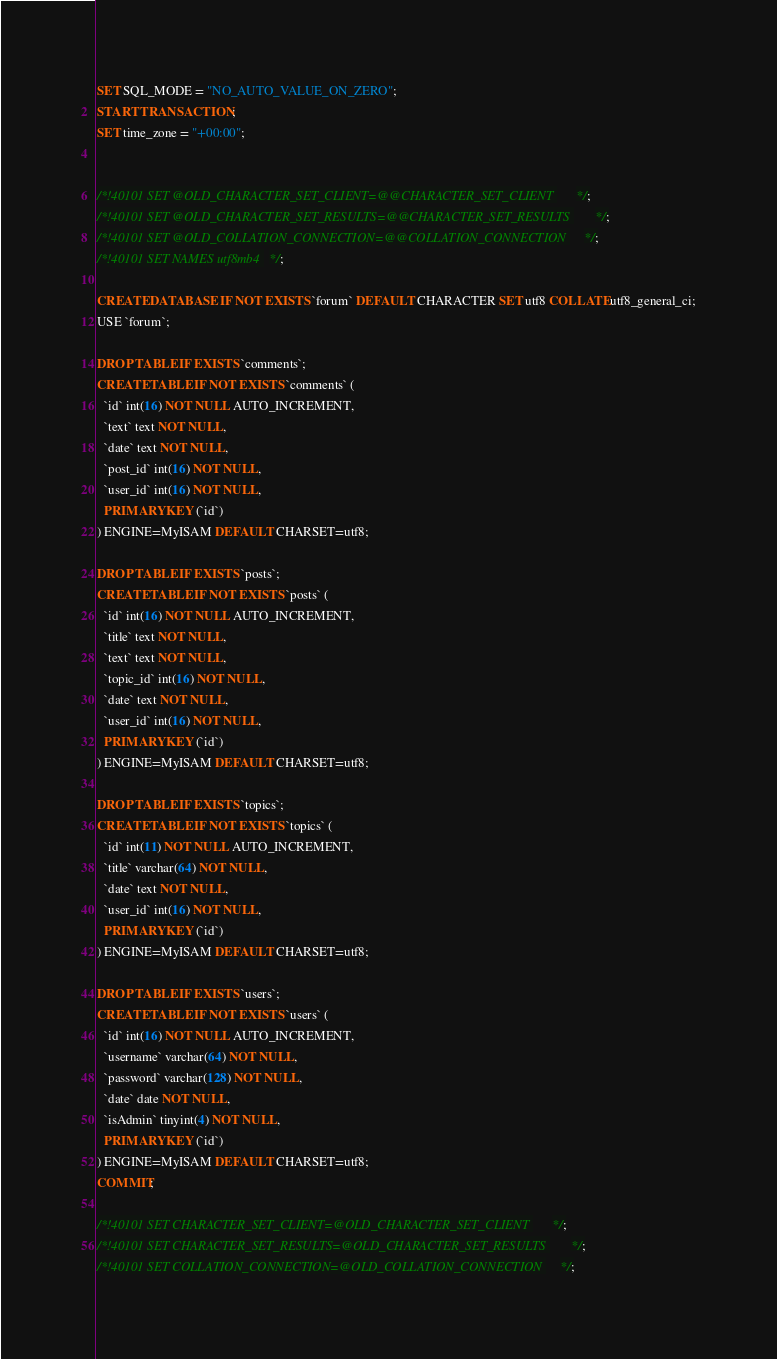<code> <loc_0><loc_0><loc_500><loc_500><_SQL_>SET SQL_MODE = "NO_AUTO_VALUE_ON_ZERO";
START TRANSACTION;
SET time_zone = "+00:00";


/*!40101 SET @OLD_CHARACTER_SET_CLIENT=@@CHARACTER_SET_CLIENT */;
/*!40101 SET @OLD_CHARACTER_SET_RESULTS=@@CHARACTER_SET_RESULTS */;
/*!40101 SET @OLD_COLLATION_CONNECTION=@@COLLATION_CONNECTION */;
/*!40101 SET NAMES utf8mb4 */;

CREATE DATABASE IF NOT EXISTS `forum` DEFAULT CHARACTER SET utf8 COLLATE utf8_general_ci;
USE `forum`;

DROP TABLE IF EXISTS `comments`;
CREATE TABLE IF NOT EXISTS `comments` (
  `id` int(16) NOT NULL AUTO_INCREMENT,
  `text` text NOT NULL,
  `date` text NOT NULL,
  `post_id` int(16) NOT NULL,
  `user_id` int(16) NOT NULL,
  PRIMARY KEY (`id`)
) ENGINE=MyISAM DEFAULT CHARSET=utf8;

DROP TABLE IF EXISTS `posts`;
CREATE TABLE IF NOT EXISTS `posts` (
  `id` int(16) NOT NULL AUTO_INCREMENT,
  `title` text NOT NULL,
  `text` text NOT NULL,
  `topic_id` int(16) NOT NULL,
  `date` text NOT NULL,
  `user_id` int(16) NOT NULL,
  PRIMARY KEY (`id`)
) ENGINE=MyISAM DEFAULT CHARSET=utf8;

DROP TABLE IF EXISTS `topics`;
CREATE TABLE IF NOT EXISTS `topics` (
  `id` int(11) NOT NULL AUTO_INCREMENT,
  `title` varchar(64) NOT NULL,
  `date` text NOT NULL,
  `user_id` int(16) NOT NULL,
  PRIMARY KEY (`id`)
) ENGINE=MyISAM DEFAULT CHARSET=utf8;

DROP TABLE IF EXISTS `users`;
CREATE TABLE IF NOT EXISTS `users` (
  `id` int(16) NOT NULL AUTO_INCREMENT,
  `username` varchar(64) NOT NULL,
  `password` varchar(128) NOT NULL,
  `date` date NOT NULL,
  `isAdmin` tinyint(4) NOT NULL,
  PRIMARY KEY (`id`)
) ENGINE=MyISAM DEFAULT CHARSET=utf8;
COMMIT;

/*!40101 SET CHARACTER_SET_CLIENT=@OLD_CHARACTER_SET_CLIENT */;
/*!40101 SET CHARACTER_SET_RESULTS=@OLD_CHARACTER_SET_RESULTS */;
/*!40101 SET COLLATION_CONNECTION=@OLD_COLLATION_CONNECTION */;
</code> 